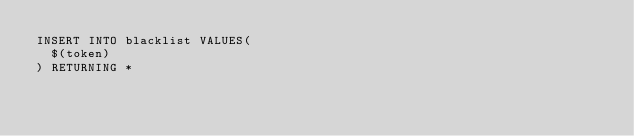<code> <loc_0><loc_0><loc_500><loc_500><_SQL_>INSERT INTO blacklist VALUES(
  $(token)
) RETURNING *
</code> 